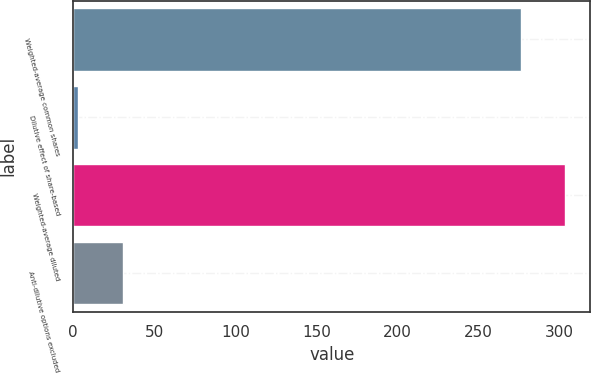Convert chart. <chart><loc_0><loc_0><loc_500><loc_500><bar_chart><fcel>Weighted-average common shares<fcel>Dilutive effect of share-based<fcel>Weighted-average diluted<fcel>Anti-dilutive options excluded<nl><fcel>276<fcel>3<fcel>303.6<fcel>30.6<nl></chart> 